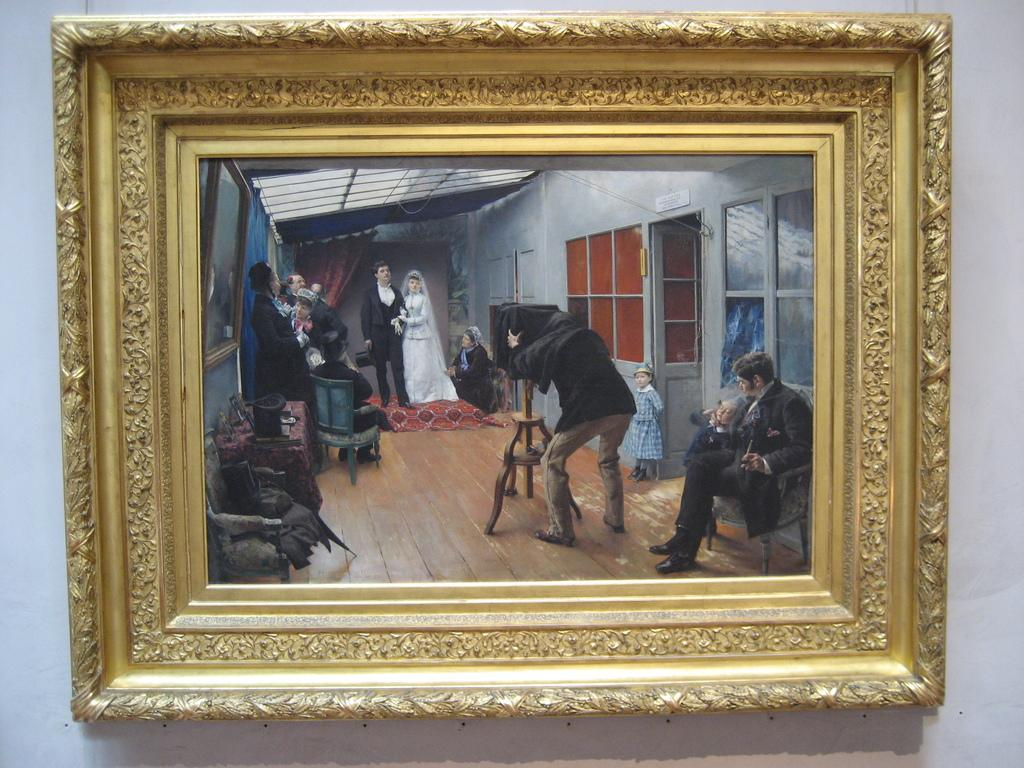What is hanging on the wall in the image? There is a photo frame on the wall. What is depicted in the photo frame? The photo frame contains a picture of a couple standing in the back. Can you describe the people in the room? There are people standing around the room. Where is the cameraman located in the image? The cameraman is beside a door. What type of punishment is being administered to the couple in the photo frame? There is no punishment being administered to the couple in the photo frame; it is a picture of them standing together. What type of sofa is present in the image? There is no sofa present in the image. 